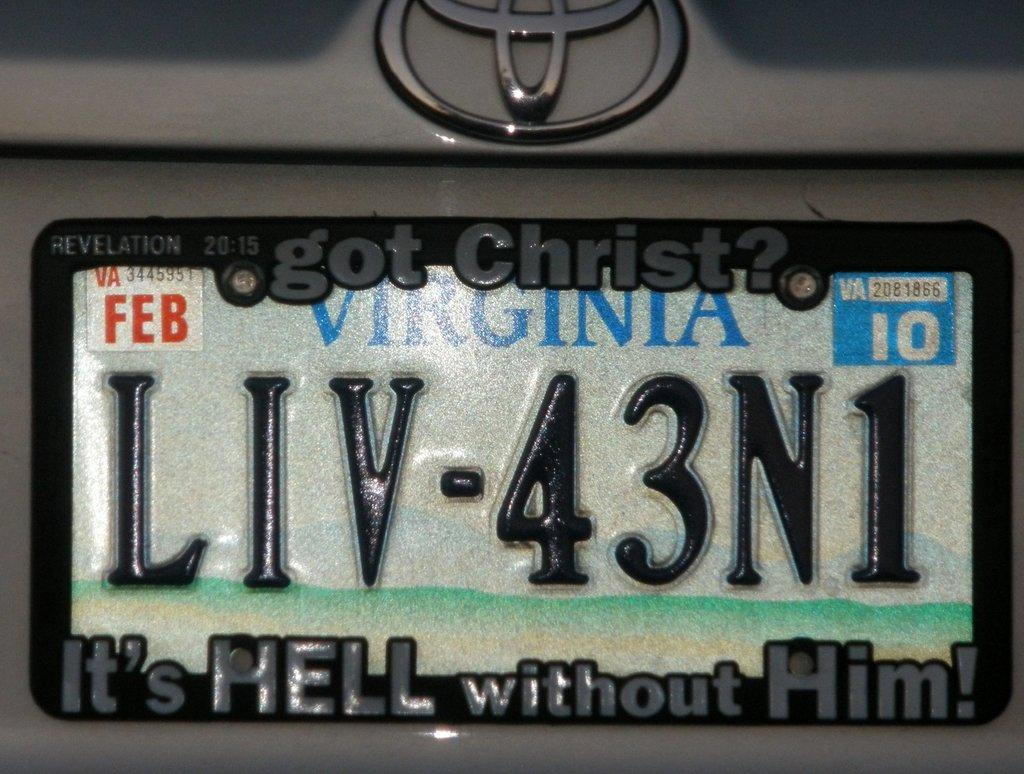<image>
Relay a brief, clear account of the picture shown. The Virginia car tag, LIV-43N1, expired Feb 2010. 